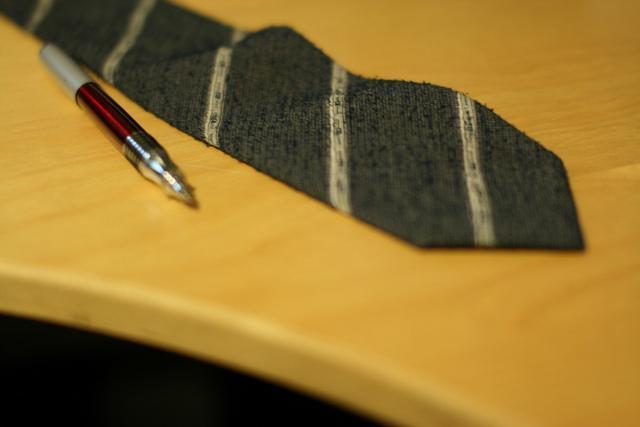How many items are in this photo?
Give a very brief answer. 2. 